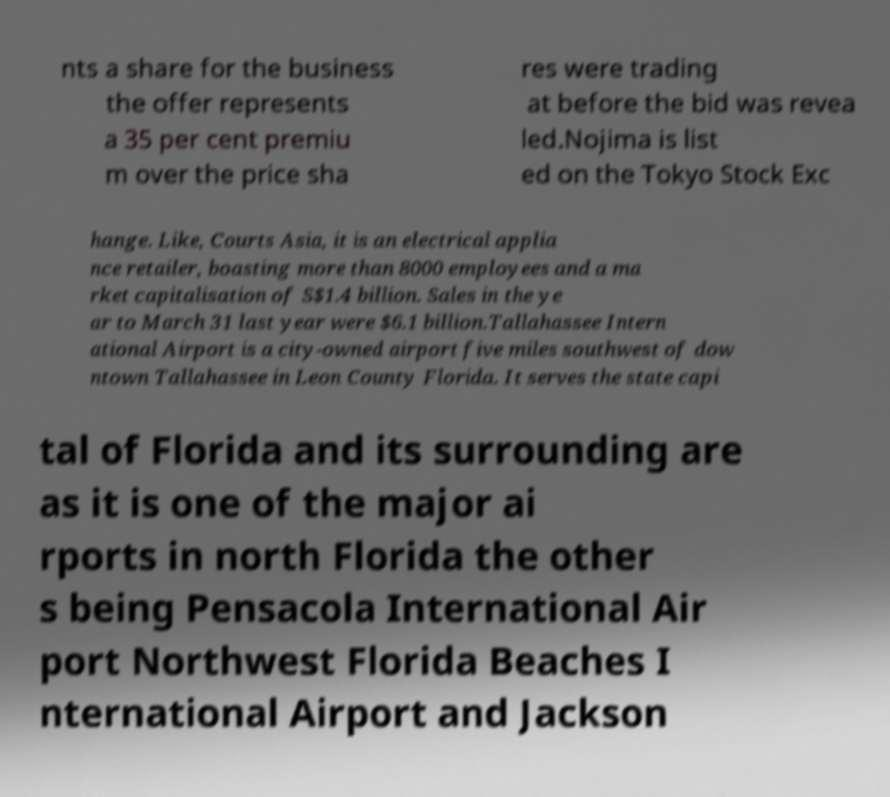Please read and relay the text visible in this image. What does it say? nts a share for the business the offer represents a 35 per cent premiu m over the price sha res were trading at before the bid was revea led.Nojima is list ed on the Tokyo Stock Exc hange. Like, Courts Asia, it is an electrical applia nce retailer, boasting more than 8000 employees and a ma rket capitalisation of S$1.4 billion. Sales in the ye ar to March 31 last year were $6.1 billion.Tallahassee Intern ational Airport is a city-owned airport five miles southwest of dow ntown Tallahassee in Leon County Florida. It serves the state capi tal of Florida and its surrounding are as it is one of the major ai rports in north Florida the other s being Pensacola International Air port Northwest Florida Beaches I nternational Airport and Jackson 